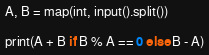<code> <loc_0><loc_0><loc_500><loc_500><_Python_>A, B = map(int, input().split())

print(A + B if B % A == 0 else B - A)</code> 